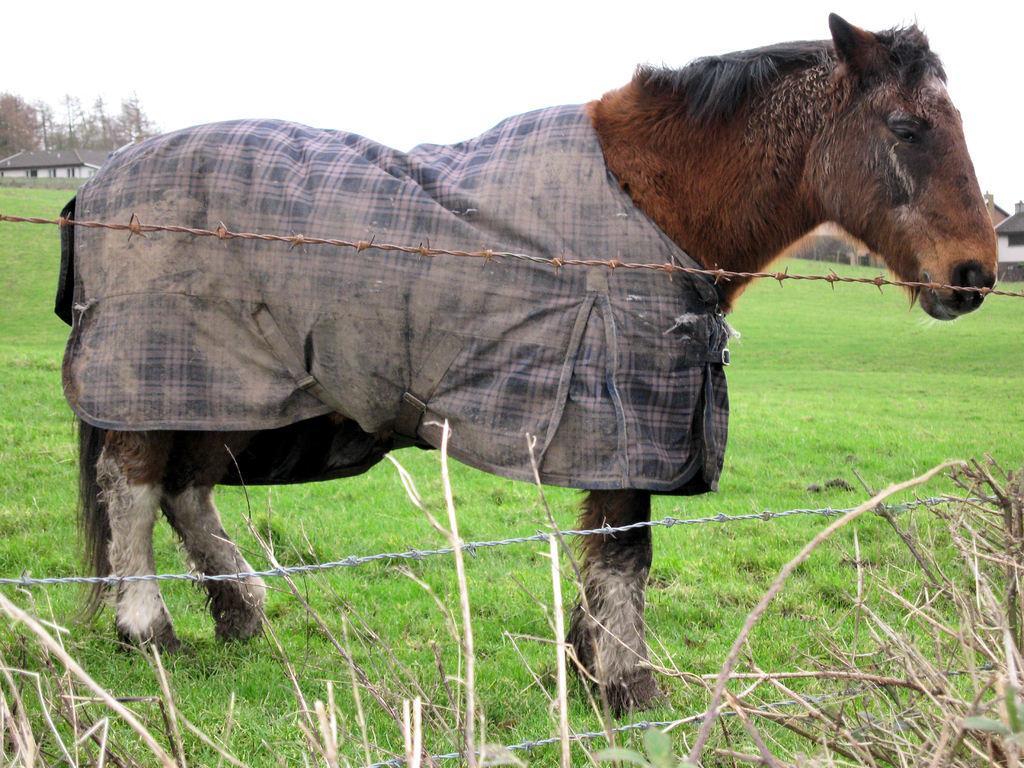Can you describe this image briefly? This image consists of a horse in brown color. At the bottom, there is green grass. To the left, there is a house. 